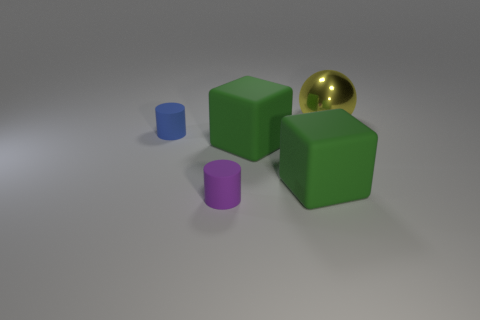Add 1 large green things. How many objects exist? 6 Subtract all spheres. How many objects are left? 4 Add 2 large blue cylinders. How many large blue cylinders exist? 2 Subtract 0 yellow blocks. How many objects are left? 5 Subtract all large yellow metal spheres. Subtract all purple shiny cylinders. How many objects are left? 4 Add 2 tiny blue objects. How many tiny blue objects are left? 3 